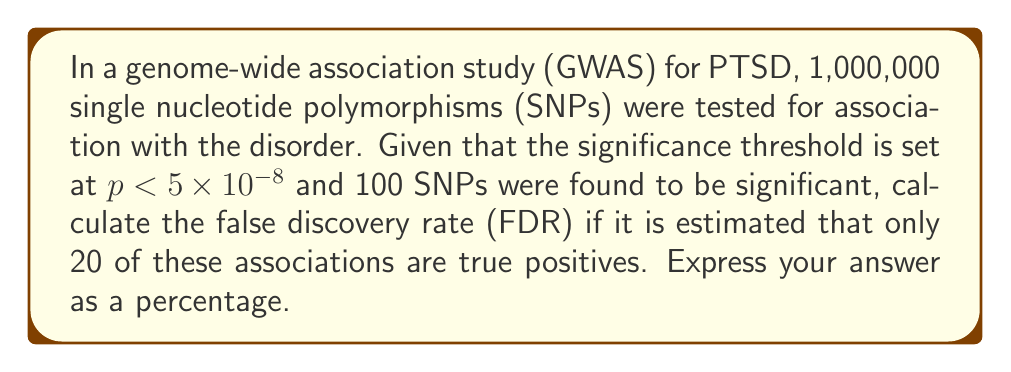Can you solve this math problem? To solve this problem, we need to understand the concept of false discovery rate (FDR) in the context of GWAS for PTSD. The FDR is the proportion of false positive results among all significant results.

Let's break down the given information:
1. Total SNPs tested: 1,000,000
2. Significance threshold: $p < 5 \times 10^{-8}$
3. Number of significant SNPs: 100
4. Estimated true positives: 20

To calculate the FDR:

1. First, we need to determine the number of false positives:
   False positives = Total significant SNPs - True positives
   $$ \text{False positives} = 100 - 20 = 80 $$

2. The FDR is calculated as:
   $$ \text{FDR} = \frac{\text{Number of false positives}}{\text{Total number of significant results}} $$

3. Plugging in our values:
   $$ \text{FDR} = \frac{80}{100} = 0.80 $$

4. To express this as a percentage, we multiply by 100:
   $$ \text{FDR} = 0.80 \times 100\% = 80\% $$

Therefore, the false discovery rate in this GWAS for PTSD is 80%.
Answer: 80% 